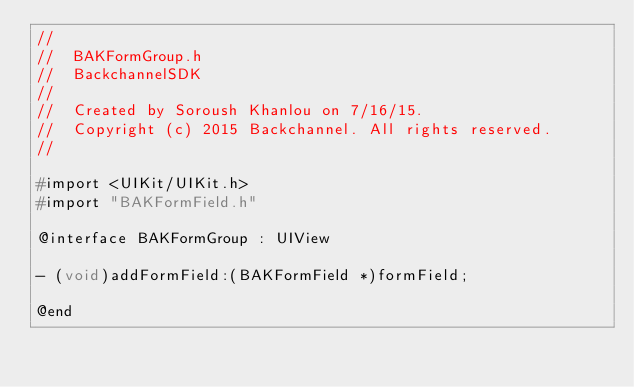Convert code to text. <code><loc_0><loc_0><loc_500><loc_500><_C_>//
//  BAKFormGroup.h
//  BackchannelSDK
//
//  Created by Soroush Khanlou on 7/16/15.
//  Copyright (c) 2015 Backchannel. All rights reserved.
//

#import <UIKit/UIKit.h>
#import "BAKFormField.h"

@interface BAKFormGroup : UIView

- (void)addFormField:(BAKFormField *)formField;

@end
</code> 